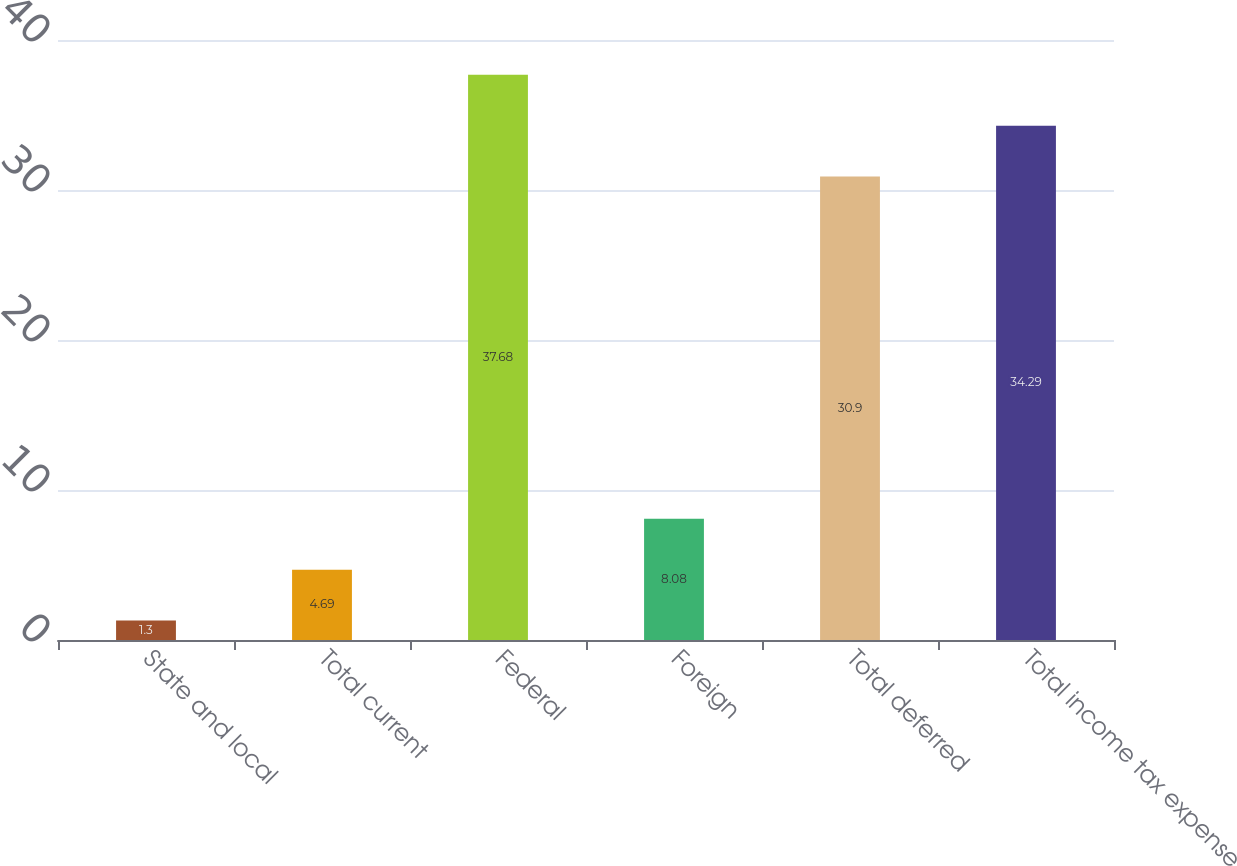<chart> <loc_0><loc_0><loc_500><loc_500><bar_chart><fcel>State and local<fcel>Total current<fcel>Federal<fcel>Foreign<fcel>Total deferred<fcel>Total income tax expense<nl><fcel>1.3<fcel>4.69<fcel>37.68<fcel>8.08<fcel>30.9<fcel>34.29<nl></chart> 